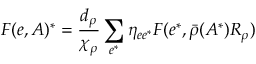<formula> <loc_0><loc_0><loc_500><loc_500>F ( e , A ) ^ { * } = \frac { d _ { \rho } } { \chi _ { \rho } } \sum _ { e ^ { * } } \eta _ { e e ^ { * } } F ( e ^ { * } , \bar { \rho } ( A ^ { * } ) R _ { \rho } )</formula> 